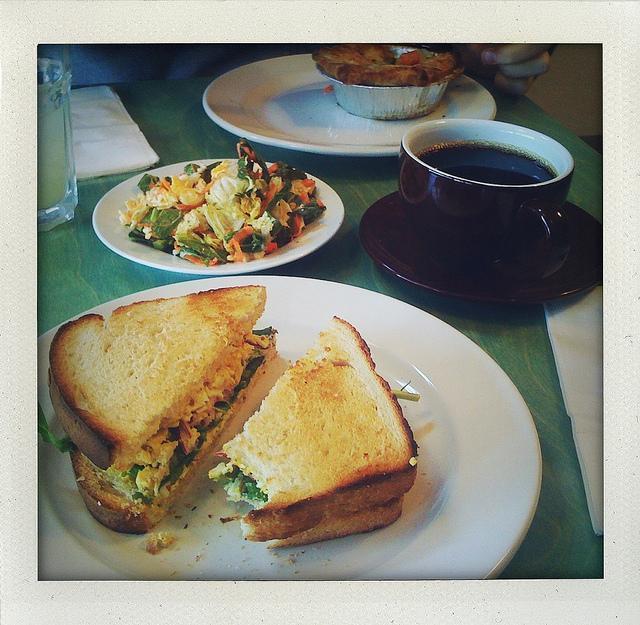How many plates are pictured?
Give a very brief answer. 4. How many bowls are there?
Give a very brief answer. 1. How many cups are there?
Give a very brief answer. 2. How many sandwiches are in the photo?
Give a very brief answer. 2. 